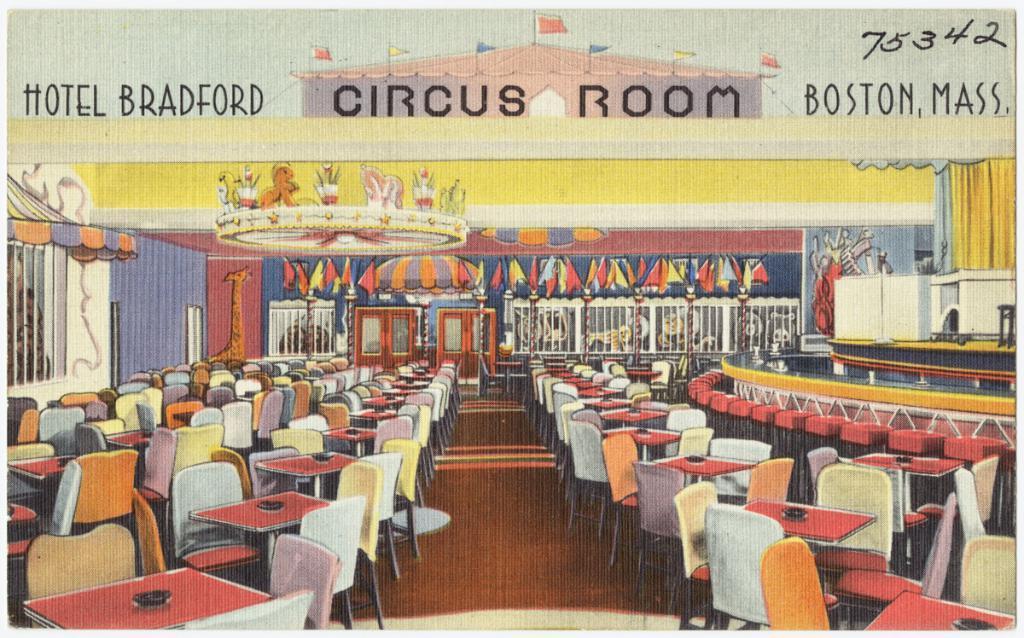In one or two sentences, can you explain what this image depicts? It is a poster. Here we can see so many chairs, tables, floor, doors, flags, walls and grills. Top of the image, we can see some text, flags and numbers. 